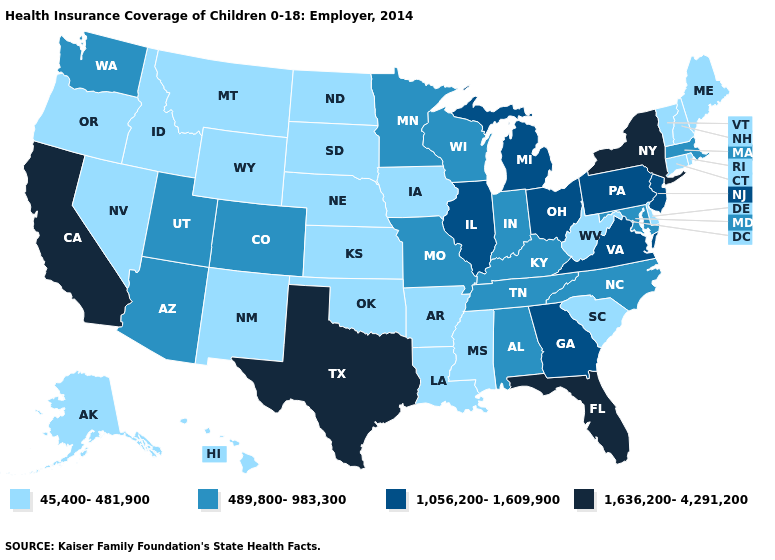Name the states that have a value in the range 1,056,200-1,609,900?
Keep it brief. Georgia, Illinois, Michigan, New Jersey, Ohio, Pennsylvania, Virginia. Which states have the lowest value in the USA?
Answer briefly. Alaska, Arkansas, Connecticut, Delaware, Hawaii, Idaho, Iowa, Kansas, Louisiana, Maine, Mississippi, Montana, Nebraska, Nevada, New Hampshire, New Mexico, North Dakota, Oklahoma, Oregon, Rhode Island, South Carolina, South Dakota, Vermont, West Virginia, Wyoming. What is the value of Hawaii?
Be succinct. 45,400-481,900. Name the states that have a value in the range 1,636,200-4,291,200?
Keep it brief. California, Florida, New York, Texas. Name the states that have a value in the range 489,800-983,300?
Give a very brief answer. Alabama, Arizona, Colorado, Indiana, Kentucky, Maryland, Massachusetts, Minnesota, Missouri, North Carolina, Tennessee, Utah, Washington, Wisconsin. Among the states that border North Dakota , does Montana have the lowest value?
Quick response, please. Yes. Does Oklahoma have the lowest value in the South?
Answer briefly. Yes. Name the states that have a value in the range 1,056,200-1,609,900?
Quick response, please. Georgia, Illinois, Michigan, New Jersey, Ohio, Pennsylvania, Virginia. Among the states that border Pennsylvania , does New York have the highest value?
Concise answer only. Yes. What is the highest value in the USA?
Be succinct. 1,636,200-4,291,200. What is the lowest value in the Northeast?
Concise answer only. 45,400-481,900. Does New York have the highest value in the Northeast?
Write a very short answer. Yes. Does Rhode Island have a lower value than Utah?
Short answer required. Yes. What is the highest value in the Northeast ?
Quick response, please. 1,636,200-4,291,200. Name the states that have a value in the range 1,056,200-1,609,900?
Quick response, please. Georgia, Illinois, Michigan, New Jersey, Ohio, Pennsylvania, Virginia. 